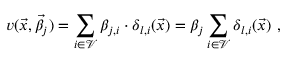Convert formula to latex. <formula><loc_0><loc_0><loc_500><loc_500>v ( \vec { x } , \vec { \beta _ { j } } ) = \sum _ { i \in \mathcal { V } } \beta _ { j , i } \cdot \delta _ { l , i } ( \vec { x } ) = \beta _ { j } \sum _ { i \in \mathcal { V } } \delta _ { l , i } ( \vec { x } ) \ ,</formula> 